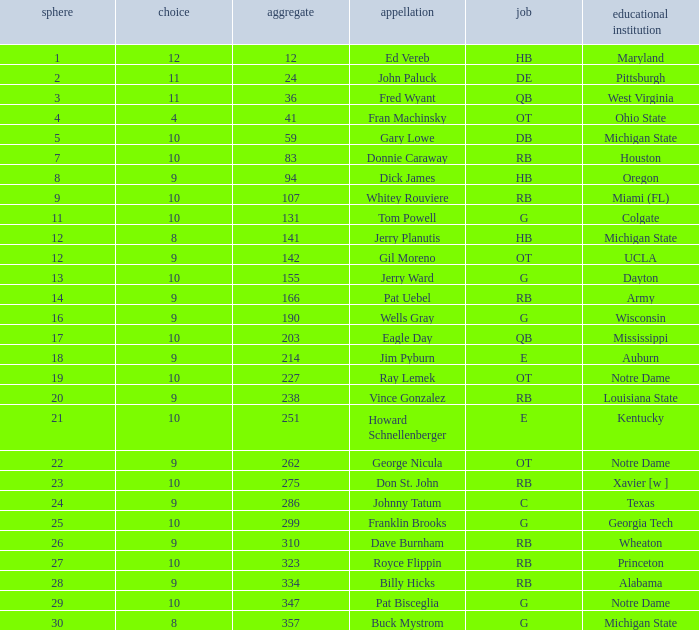What is the highest overall pick number for george nicula who had a pick smaller than 9? None. 